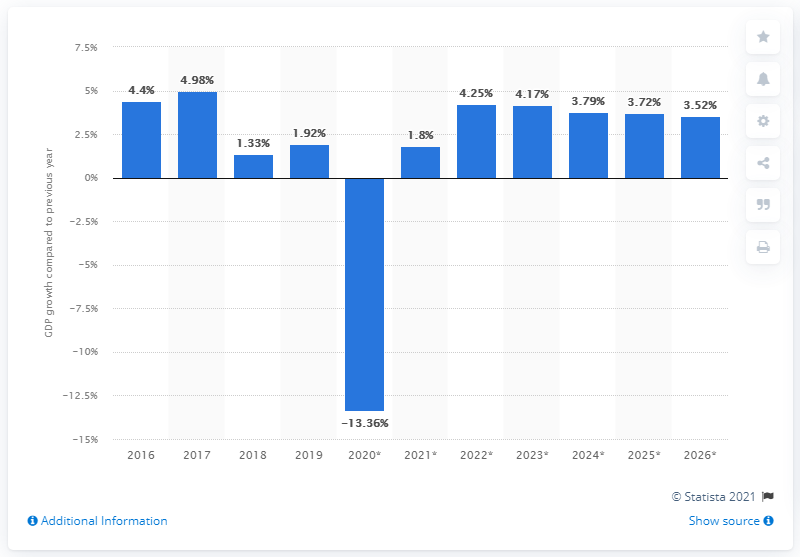Give some essential details in this illustration. In 2016, the Seychelles experienced the highest growth in real GDP compared to other years. In 2019, the real gross domestic product (GDP) of Seychelles grew by 1.92%. 